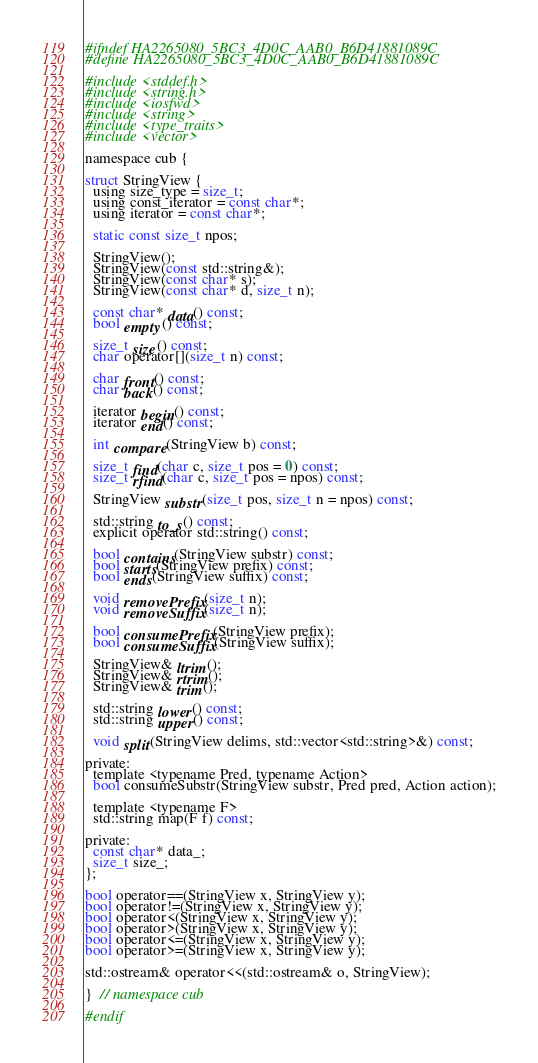<code> <loc_0><loc_0><loc_500><loc_500><_C_>#ifndef HA2265080_5BC3_4D0C_AAB0_B6D41881089C
#define HA2265080_5BC3_4D0C_AAB0_B6D41881089C

#include <stddef.h>
#include <string.h>
#include <iosfwd>
#include <string>
#include <type_traits>
#include <vector>

namespace cub {

struct StringView {
  using size_type = size_t;
  using const_iterator = const char*;
  using iterator = const char*;

  static const size_t npos;

  StringView();
  StringView(const std::string&);
  StringView(const char* s);
  StringView(const char* d, size_t n);

  const char* data() const;
  bool empty() const;

  size_t size() const;
  char operator[](size_t n) const;

  char front() const;
  char back() const;

  iterator begin() const;
  iterator end() const;

  int compare(StringView b) const;

  size_t find(char c, size_t pos = 0) const;
  size_t rfind(char c, size_t pos = npos) const;

  StringView substr(size_t pos, size_t n = npos) const;

  std::string to_s() const;
  explicit operator std::string() const;

  bool contains(StringView substr) const;
  bool starts(StringView prefix) const;
  bool ends(StringView suffix) const;

  void removePrefix(size_t n);
  void removeSuffix(size_t n);

  bool consumePrefix(StringView prefix);
  bool consumeSuffix(StringView suffix);

  StringView& ltrim();
  StringView& rtrim();
  StringView& trim();

  std::string lower() const;
  std::string upper() const;

  void split(StringView delims, std::vector<std::string>&) const;

private:
  template <typename Pred, typename Action>
  bool consumeSubstr(StringView substr, Pred pred, Action action);

  template <typename F>
  std::string map(F f) const;

private:
  const char* data_;
  size_t size_;
};

bool operator==(StringView x, StringView y);
bool operator!=(StringView x, StringView y);
bool operator<(StringView x, StringView y);
bool operator>(StringView x, StringView y);
bool operator<=(StringView x, StringView y);
bool operator>=(StringView x, StringView y);

std::ostream& operator<<(std::ostream& o, StringView);

}  // namespace cub

#endif
</code> 